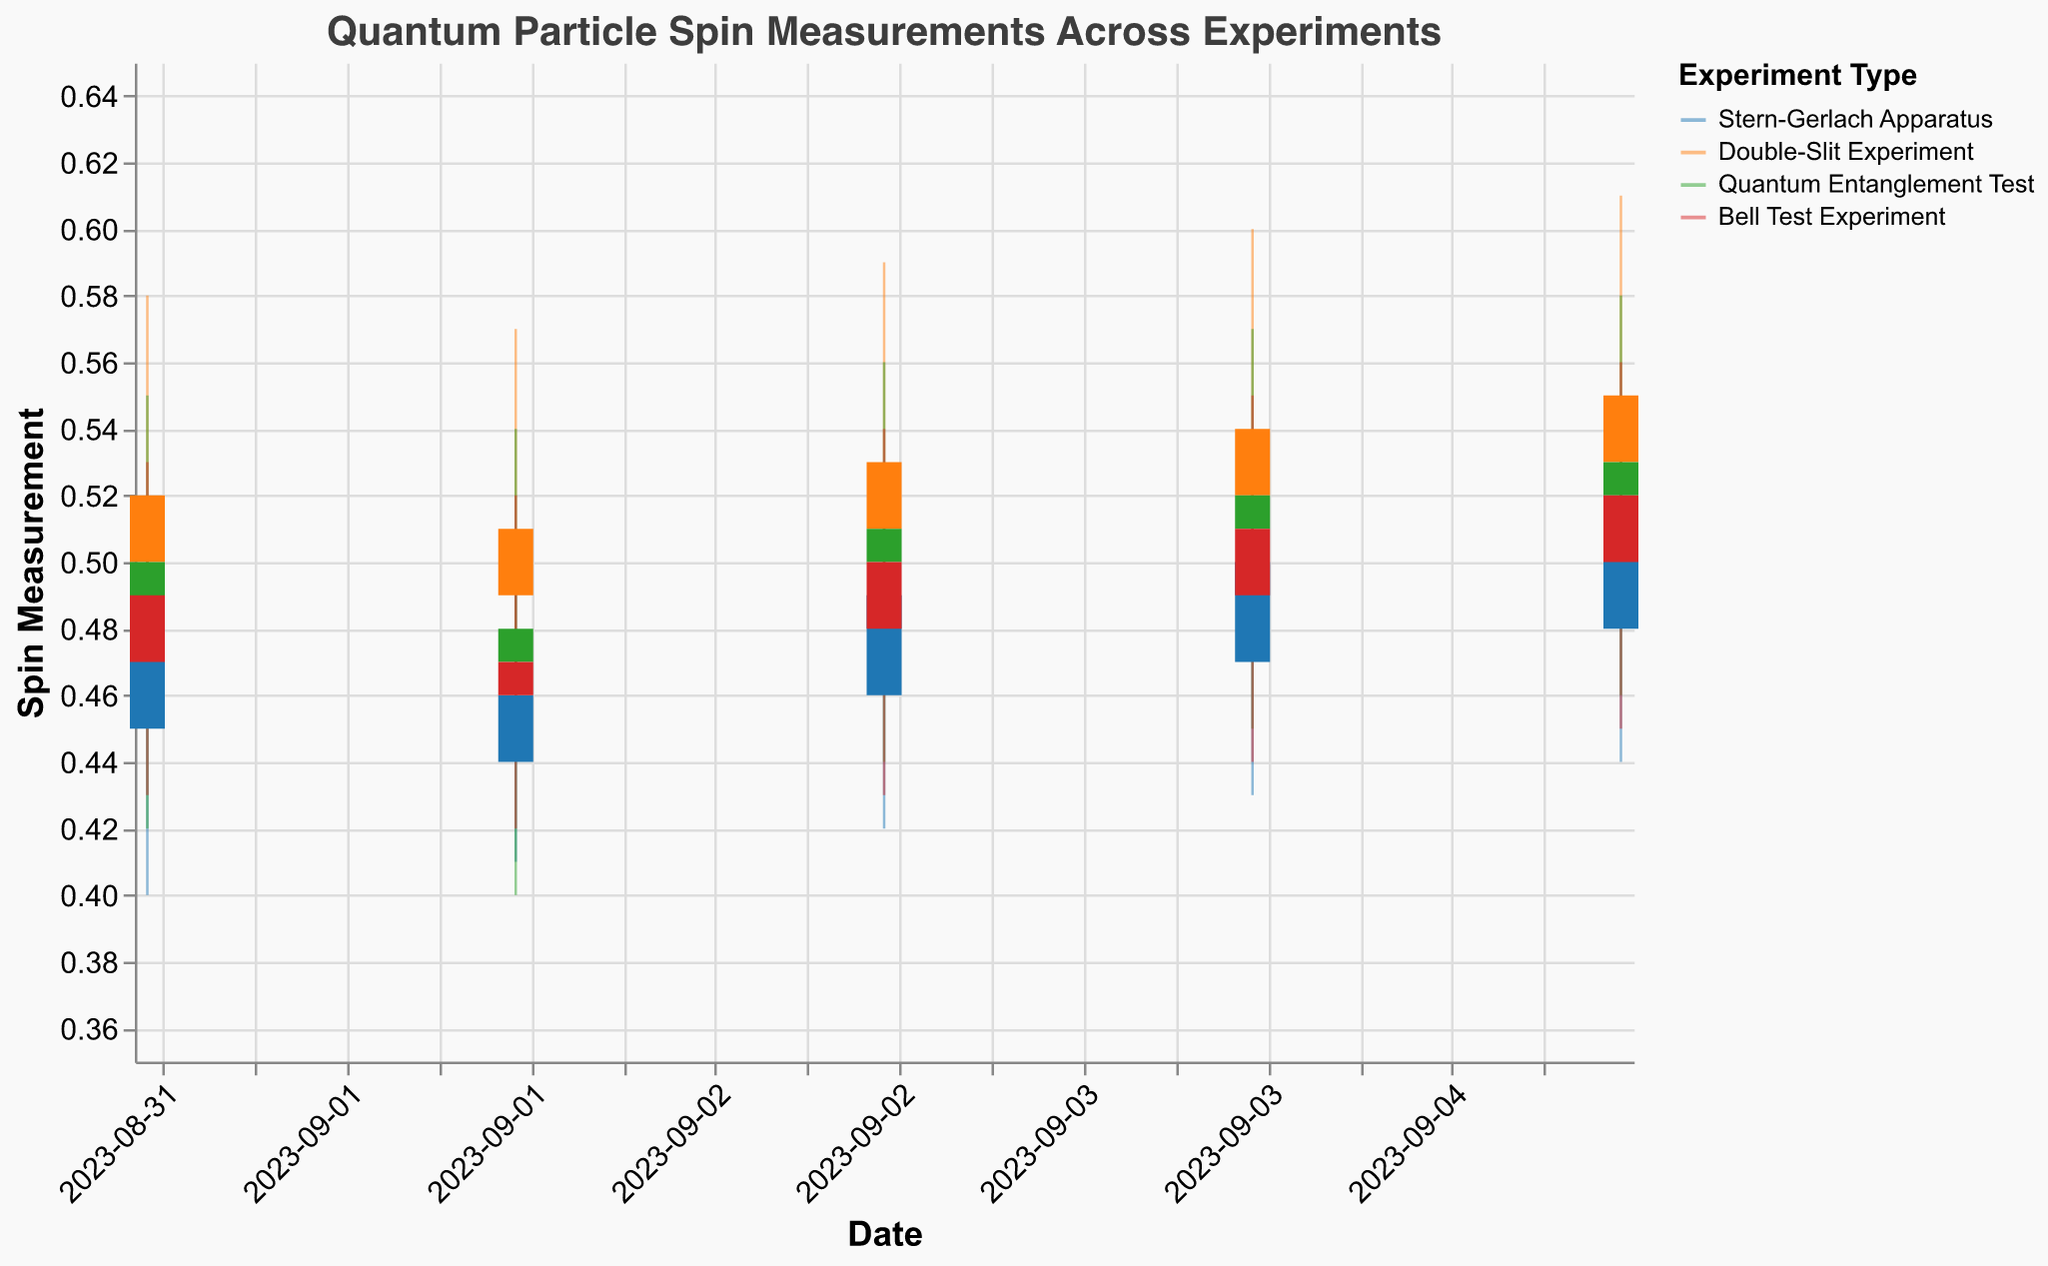What is the title of the figure? The title can be found at the top of the figure in a larger font size than the rest of the text, it describes the overall theme of the plot.
Answer: Quantum Particle Spin Measurements Across Experiments What is the spin measurement range on the y-axis? The range for the y-axis is visible on the plot itself, often shown as numbered ticks from the lowest to the highest value. Here, it is from 0.35 to 0.65.
Answer: 0.35 to 0.65 Which experiment had the highest close spin measurement on 2023-09-05? To find this, locate the date 2023-09-05 on the x-axis, then compare the close values (top of the candlestick) for each experiment. The Double-Slit Experiment closed at 0.55, which is higher than the others.
Answer: Double-Slit Experiment For the Quantum Entanglement Test, calculate the average closing value over the given dates. Add the closing values for the Quantum Entanglement Test on all given dates and divide by the number of dates: (0.50 + 0.48 + 0.51 + 0.52 + 0.53) / 5 = 2.54 / 5 = 0.508.
Answer: 0.508 On which date did the Bell Test Experiment have the smallest range between the high and low spin measurements? Calculate the difference (high - low) for each date for the Bell Test Experiment and compare them: 
2023-09-01: 0.53 - 0.43 = 0.10,
2023-09-02: 0.52 - 0.42 = 0.10,
2023-09-03: 0.54 - 0.43 = 0.11,
2023-09-04: 0.55 - 0.44 = 0.11,
2023-09-05: 0.56 - 0.45 = 0.11.
The smallest range, 0.10, occurs on both 2023-09-01 and 2023-09-02.
Answer: 2023-09-01 and 2023-09-02 What's the combined high measurement for all experiments on 2023-09-03? Add the high values for all experiments on 2023-09-03: (0.53 + 0.59 + 0.56 + 0.54) = 2.22.
Answer: 2.22 Which experiment shows the most consistent closing values over the provided dates? To determine this, observe the variation in the close values over the provided dates. The Stern-Gerlach Apparatus shows close values of (0.48, 0.46, 0.49, 0.50, 0.51) with relatively small changes.
Answer: Stern-Gerlach Apparatus 